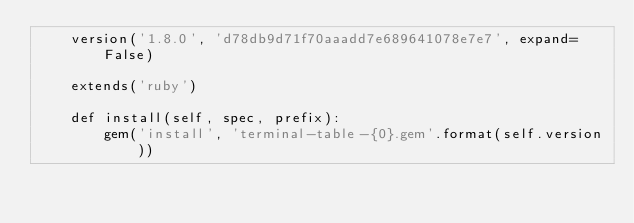<code> <loc_0><loc_0><loc_500><loc_500><_Python_>    version('1.8.0', 'd78db9d71f70aaadd7e689641078e7e7', expand=False)

    extends('ruby')

    def install(self, spec, prefix):
        gem('install', 'terminal-table-{0}.gem'.format(self.version))
</code> 